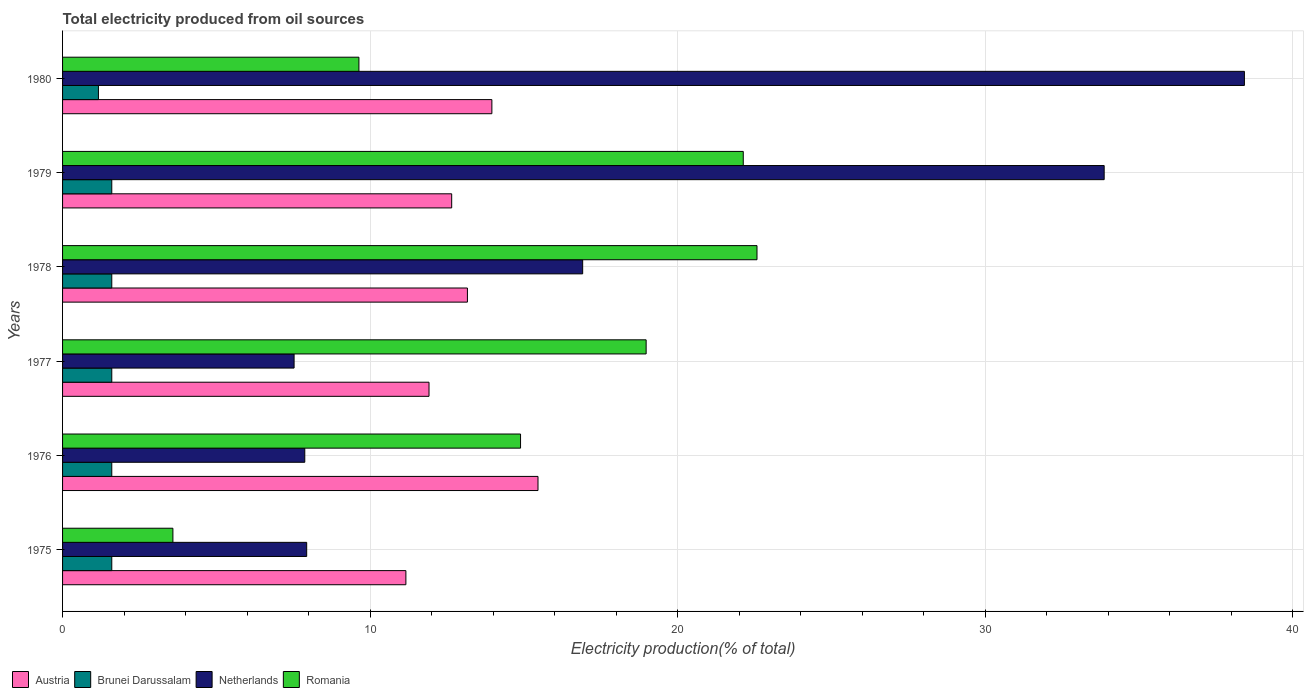How many bars are there on the 1st tick from the bottom?
Provide a short and direct response. 4. What is the label of the 5th group of bars from the top?
Give a very brief answer. 1976. In how many cases, is the number of bars for a given year not equal to the number of legend labels?
Offer a terse response. 0. What is the total electricity produced in Brunei Darussalam in 1977?
Your response must be concise. 1.6. Across all years, what is the minimum total electricity produced in Austria?
Your answer should be very brief. 11.16. In which year was the total electricity produced in Romania maximum?
Your answer should be compact. 1978. In which year was the total electricity produced in Romania minimum?
Your answer should be very brief. 1975. What is the total total electricity produced in Romania in the graph?
Ensure brevity in your answer.  91.79. What is the difference between the total electricity produced in Romania in 1975 and that in 1978?
Your answer should be compact. -18.99. What is the difference between the total electricity produced in Netherlands in 1980 and the total electricity produced in Romania in 1976?
Provide a succinct answer. 23.53. What is the average total electricity produced in Brunei Darussalam per year?
Provide a succinct answer. 1.53. In the year 1976, what is the difference between the total electricity produced in Netherlands and total electricity produced in Romania?
Provide a succinct answer. -7.01. What is the ratio of the total electricity produced in Romania in 1976 to that in 1978?
Keep it short and to the point. 0.66. Is the difference between the total electricity produced in Netherlands in 1978 and 1980 greater than the difference between the total electricity produced in Romania in 1978 and 1980?
Give a very brief answer. No. What is the difference between the highest and the second highest total electricity produced in Netherlands?
Keep it short and to the point. 4.56. What is the difference between the highest and the lowest total electricity produced in Romania?
Provide a succinct answer. 18.99. What does the 3rd bar from the top in 1975 represents?
Your answer should be very brief. Brunei Darussalam. What does the 4th bar from the bottom in 1978 represents?
Offer a terse response. Romania. Are all the bars in the graph horizontal?
Offer a very short reply. Yes. What is the difference between two consecutive major ticks on the X-axis?
Offer a terse response. 10. Are the values on the major ticks of X-axis written in scientific E-notation?
Ensure brevity in your answer.  No. Does the graph contain any zero values?
Give a very brief answer. No. Does the graph contain grids?
Your answer should be compact. Yes. Where does the legend appear in the graph?
Offer a terse response. Bottom left. How many legend labels are there?
Give a very brief answer. 4. How are the legend labels stacked?
Give a very brief answer. Horizontal. What is the title of the graph?
Offer a terse response. Total electricity produced from oil sources. What is the label or title of the X-axis?
Provide a short and direct response. Electricity production(% of total). What is the Electricity production(% of total) in Austria in 1975?
Keep it short and to the point. 11.16. What is the Electricity production(% of total) of Brunei Darussalam in 1975?
Offer a terse response. 1.6. What is the Electricity production(% of total) in Netherlands in 1975?
Keep it short and to the point. 7.94. What is the Electricity production(% of total) of Romania in 1975?
Offer a terse response. 3.59. What is the Electricity production(% of total) of Austria in 1976?
Your response must be concise. 15.46. What is the Electricity production(% of total) of Netherlands in 1976?
Your response must be concise. 7.87. What is the Electricity production(% of total) of Romania in 1976?
Your response must be concise. 14.89. What is the Electricity production(% of total) in Austria in 1977?
Provide a short and direct response. 11.91. What is the Electricity production(% of total) in Brunei Darussalam in 1977?
Offer a very short reply. 1.6. What is the Electricity production(% of total) of Netherlands in 1977?
Make the answer very short. 7.53. What is the Electricity production(% of total) of Romania in 1977?
Offer a terse response. 18.97. What is the Electricity production(% of total) of Austria in 1978?
Offer a terse response. 13.16. What is the Electricity production(% of total) in Brunei Darussalam in 1978?
Provide a short and direct response. 1.6. What is the Electricity production(% of total) of Netherlands in 1978?
Make the answer very short. 16.91. What is the Electricity production(% of total) of Romania in 1978?
Offer a terse response. 22.58. What is the Electricity production(% of total) in Austria in 1979?
Offer a very short reply. 12.65. What is the Electricity production(% of total) of Netherlands in 1979?
Provide a succinct answer. 33.86. What is the Electricity production(% of total) in Romania in 1979?
Make the answer very short. 22.13. What is the Electricity production(% of total) of Austria in 1980?
Offer a terse response. 13.96. What is the Electricity production(% of total) in Brunei Darussalam in 1980?
Provide a short and direct response. 1.17. What is the Electricity production(% of total) of Netherlands in 1980?
Provide a succinct answer. 38.42. What is the Electricity production(% of total) of Romania in 1980?
Your response must be concise. 9.63. Across all years, what is the maximum Electricity production(% of total) of Austria?
Your answer should be very brief. 15.46. Across all years, what is the maximum Electricity production(% of total) of Brunei Darussalam?
Your response must be concise. 1.6. Across all years, what is the maximum Electricity production(% of total) in Netherlands?
Your answer should be compact. 38.42. Across all years, what is the maximum Electricity production(% of total) in Romania?
Offer a very short reply. 22.58. Across all years, what is the minimum Electricity production(% of total) in Austria?
Provide a succinct answer. 11.16. Across all years, what is the minimum Electricity production(% of total) of Brunei Darussalam?
Provide a succinct answer. 1.17. Across all years, what is the minimum Electricity production(% of total) of Netherlands?
Your answer should be very brief. 7.53. Across all years, what is the minimum Electricity production(% of total) in Romania?
Offer a very short reply. 3.59. What is the total Electricity production(% of total) in Austria in the graph?
Your answer should be very brief. 78.3. What is the total Electricity production(% of total) of Brunei Darussalam in the graph?
Keep it short and to the point. 9.17. What is the total Electricity production(% of total) in Netherlands in the graph?
Provide a short and direct response. 112.53. What is the total Electricity production(% of total) of Romania in the graph?
Provide a succinct answer. 91.79. What is the difference between the Electricity production(% of total) of Austria in 1975 and that in 1976?
Keep it short and to the point. -4.29. What is the difference between the Electricity production(% of total) in Netherlands in 1975 and that in 1976?
Your answer should be compact. 0.06. What is the difference between the Electricity production(% of total) in Romania in 1975 and that in 1976?
Keep it short and to the point. -11.3. What is the difference between the Electricity production(% of total) in Austria in 1975 and that in 1977?
Keep it short and to the point. -0.75. What is the difference between the Electricity production(% of total) of Netherlands in 1975 and that in 1977?
Make the answer very short. 0.41. What is the difference between the Electricity production(% of total) of Romania in 1975 and that in 1977?
Make the answer very short. -15.38. What is the difference between the Electricity production(% of total) of Austria in 1975 and that in 1978?
Your answer should be compact. -2. What is the difference between the Electricity production(% of total) of Brunei Darussalam in 1975 and that in 1978?
Provide a short and direct response. 0. What is the difference between the Electricity production(% of total) of Netherlands in 1975 and that in 1978?
Offer a very short reply. -8.97. What is the difference between the Electricity production(% of total) of Romania in 1975 and that in 1978?
Your answer should be very brief. -18.99. What is the difference between the Electricity production(% of total) in Austria in 1975 and that in 1979?
Keep it short and to the point. -1.49. What is the difference between the Electricity production(% of total) in Brunei Darussalam in 1975 and that in 1979?
Ensure brevity in your answer.  0. What is the difference between the Electricity production(% of total) of Netherlands in 1975 and that in 1979?
Provide a short and direct response. -25.93. What is the difference between the Electricity production(% of total) in Romania in 1975 and that in 1979?
Offer a terse response. -18.54. What is the difference between the Electricity production(% of total) in Austria in 1975 and that in 1980?
Keep it short and to the point. -2.8. What is the difference between the Electricity production(% of total) in Brunei Darussalam in 1975 and that in 1980?
Your response must be concise. 0.43. What is the difference between the Electricity production(% of total) of Netherlands in 1975 and that in 1980?
Ensure brevity in your answer.  -30.48. What is the difference between the Electricity production(% of total) of Romania in 1975 and that in 1980?
Your answer should be compact. -6.05. What is the difference between the Electricity production(% of total) in Austria in 1976 and that in 1977?
Ensure brevity in your answer.  3.54. What is the difference between the Electricity production(% of total) in Netherlands in 1976 and that in 1977?
Provide a succinct answer. 0.35. What is the difference between the Electricity production(% of total) of Romania in 1976 and that in 1977?
Ensure brevity in your answer.  -4.08. What is the difference between the Electricity production(% of total) of Austria in 1976 and that in 1978?
Ensure brevity in your answer.  2.29. What is the difference between the Electricity production(% of total) in Netherlands in 1976 and that in 1978?
Offer a terse response. -9.03. What is the difference between the Electricity production(% of total) of Romania in 1976 and that in 1978?
Keep it short and to the point. -7.69. What is the difference between the Electricity production(% of total) of Austria in 1976 and that in 1979?
Ensure brevity in your answer.  2.81. What is the difference between the Electricity production(% of total) in Netherlands in 1976 and that in 1979?
Offer a very short reply. -25.99. What is the difference between the Electricity production(% of total) of Romania in 1976 and that in 1979?
Your response must be concise. -7.24. What is the difference between the Electricity production(% of total) in Austria in 1976 and that in 1980?
Keep it short and to the point. 1.5. What is the difference between the Electricity production(% of total) of Brunei Darussalam in 1976 and that in 1980?
Make the answer very short. 0.43. What is the difference between the Electricity production(% of total) of Netherlands in 1976 and that in 1980?
Your response must be concise. -30.55. What is the difference between the Electricity production(% of total) of Romania in 1976 and that in 1980?
Offer a terse response. 5.25. What is the difference between the Electricity production(% of total) in Austria in 1977 and that in 1978?
Give a very brief answer. -1.25. What is the difference between the Electricity production(% of total) in Netherlands in 1977 and that in 1978?
Make the answer very short. -9.38. What is the difference between the Electricity production(% of total) of Romania in 1977 and that in 1978?
Give a very brief answer. -3.6. What is the difference between the Electricity production(% of total) in Austria in 1977 and that in 1979?
Make the answer very short. -0.74. What is the difference between the Electricity production(% of total) of Netherlands in 1977 and that in 1979?
Provide a succinct answer. -26.34. What is the difference between the Electricity production(% of total) of Romania in 1977 and that in 1979?
Ensure brevity in your answer.  -3.16. What is the difference between the Electricity production(% of total) in Austria in 1977 and that in 1980?
Provide a short and direct response. -2.04. What is the difference between the Electricity production(% of total) in Brunei Darussalam in 1977 and that in 1980?
Your answer should be compact. 0.43. What is the difference between the Electricity production(% of total) in Netherlands in 1977 and that in 1980?
Your answer should be compact. -30.89. What is the difference between the Electricity production(% of total) of Romania in 1977 and that in 1980?
Your response must be concise. 9.34. What is the difference between the Electricity production(% of total) of Austria in 1978 and that in 1979?
Provide a short and direct response. 0.51. What is the difference between the Electricity production(% of total) in Brunei Darussalam in 1978 and that in 1979?
Offer a very short reply. 0. What is the difference between the Electricity production(% of total) of Netherlands in 1978 and that in 1979?
Make the answer very short. -16.95. What is the difference between the Electricity production(% of total) in Romania in 1978 and that in 1979?
Keep it short and to the point. 0.45. What is the difference between the Electricity production(% of total) in Austria in 1978 and that in 1980?
Your response must be concise. -0.79. What is the difference between the Electricity production(% of total) of Brunei Darussalam in 1978 and that in 1980?
Your answer should be compact. 0.43. What is the difference between the Electricity production(% of total) in Netherlands in 1978 and that in 1980?
Provide a short and direct response. -21.51. What is the difference between the Electricity production(% of total) in Romania in 1978 and that in 1980?
Your response must be concise. 12.94. What is the difference between the Electricity production(% of total) in Austria in 1979 and that in 1980?
Make the answer very short. -1.31. What is the difference between the Electricity production(% of total) of Brunei Darussalam in 1979 and that in 1980?
Give a very brief answer. 0.43. What is the difference between the Electricity production(% of total) of Netherlands in 1979 and that in 1980?
Ensure brevity in your answer.  -4.56. What is the difference between the Electricity production(% of total) in Romania in 1979 and that in 1980?
Your answer should be very brief. 12.49. What is the difference between the Electricity production(% of total) in Austria in 1975 and the Electricity production(% of total) in Brunei Darussalam in 1976?
Your answer should be compact. 9.56. What is the difference between the Electricity production(% of total) in Austria in 1975 and the Electricity production(% of total) in Netherlands in 1976?
Your answer should be very brief. 3.29. What is the difference between the Electricity production(% of total) in Austria in 1975 and the Electricity production(% of total) in Romania in 1976?
Your response must be concise. -3.73. What is the difference between the Electricity production(% of total) in Brunei Darussalam in 1975 and the Electricity production(% of total) in Netherlands in 1976?
Provide a short and direct response. -6.27. What is the difference between the Electricity production(% of total) in Brunei Darussalam in 1975 and the Electricity production(% of total) in Romania in 1976?
Offer a terse response. -13.29. What is the difference between the Electricity production(% of total) in Netherlands in 1975 and the Electricity production(% of total) in Romania in 1976?
Offer a terse response. -6.95. What is the difference between the Electricity production(% of total) in Austria in 1975 and the Electricity production(% of total) in Brunei Darussalam in 1977?
Offer a very short reply. 9.56. What is the difference between the Electricity production(% of total) in Austria in 1975 and the Electricity production(% of total) in Netherlands in 1977?
Keep it short and to the point. 3.63. What is the difference between the Electricity production(% of total) of Austria in 1975 and the Electricity production(% of total) of Romania in 1977?
Provide a short and direct response. -7.81. What is the difference between the Electricity production(% of total) in Brunei Darussalam in 1975 and the Electricity production(% of total) in Netherlands in 1977?
Keep it short and to the point. -5.93. What is the difference between the Electricity production(% of total) of Brunei Darussalam in 1975 and the Electricity production(% of total) of Romania in 1977?
Your answer should be compact. -17.37. What is the difference between the Electricity production(% of total) in Netherlands in 1975 and the Electricity production(% of total) in Romania in 1977?
Make the answer very short. -11.04. What is the difference between the Electricity production(% of total) in Austria in 1975 and the Electricity production(% of total) in Brunei Darussalam in 1978?
Provide a succinct answer. 9.56. What is the difference between the Electricity production(% of total) in Austria in 1975 and the Electricity production(% of total) in Netherlands in 1978?
Provide a short and direct response. -5.75. What is the difference between the Electricity production(% of total) in Austria in 1975 and the Electricity production(% of total) in Romania in 1978?
Ensure brevity in your answer.  -11.41. What is the difference between the Electricity production(% of total) in Brunei Darussalam in 1975 and the Electricity production(% of total) in Netherlands in 1978?
Provide a succinct answer. -15.31. What is the difference between the Electricity production(% of total) in Brunei Darussalam in 1975 and the Electricity production(% of total) in Romania in 1978?
Your answer should be very brief. -20.98. What is the difference between the Electricity production(% of total) in Netherlands in 1975 and the Electricity production(% of total) in Romania in 1978?
Keep it short and to the point. -14.64. What is the difference between the Electricity production(% of total) of Austria in 1975 and the Electricity production(% of total) of Brunei Darussalam in 1979?
Offer a very short reply. 9.56. What is the difference between the Electricity production(% of total) in Austria in 1975 and the Electricity production(% of total) in Netherlands in 1979?
Offer a very short reply. -22.7. What is the difference between the Electricity production(% of total) of Austria in 1975 and the Electricity production(% of total) of Romania in 1979?
Provide a succinct answer. -10.97. What is the difference between the Electricity production(% of total) in Brunei Darussalam in 1975 and the Electricity production(% of total) in Netherlands in 1979?
Provide a short and direct response. -32.26. What is the difference between the Electricity production(% of total) of Brunei Darussalam in 1975 and the Electricity production(% of total) of Romania in 1979?
Offer a terse response. -20.53. What is the difference between the Electricity production(% of total) of Netherlands in 1975 and the Electricity production(% of total) of Romania in 1979?
Keep it short and to the point. -14.19. What is the difference between the Electricity production(% of total) of Austria in 1975 and the Electricity production(% of total) of Brunei Darussalam in 1980?
Provide a short and direct response. 10. What is the difference between the Electricity production(% of total) of Austria in 1975 and the Electricity production(% of total) of Netherlands in 1980?
Your response must be concise. -27.26. What is the difference between the Electricity production(% of total) of Austria in 1975 and the Electricity production(% of total) of Romania in 1980?
Your answer should be compact. 1.53. What is the difference between the Electricity production(% of total) in Brunei Darussalam in 1975 and the Electricity production(% of total) in Netherlands in 1980?
Make the answer very short. -36.82. What is the difference between the Electricity production(% of total) in Brunei Darussalam in 1975 and the Electricity production(% of total) in Romania in 1980?
Your answer should be compact. -8.03. What is the difference between the Electricity production(% of total) of Netherlands in 1975 and the Electricity production(% of total) of Romania in 1980?
Give a very brief answer. -1.7. What is the difference between the Electricity production(% of total) of Austria in 1976 and the Electricity production(% of total) of Brunei Darussalam in 1977?
Provide a succinct answer. 13.86. What is the difference between the Electricity production(% of total) of Austria in 1976 and the Electricity production(% of total) of Netherlands in 1977?
Your response must be concise. 7.93. What is the difference between the Electricity production(% of total) of Austria in 1976 and the Electricity production(% of total) of Romania in 1977?
Ensure brevity in your answer.  -3.52. What is the difference between the Electricity production(% of total) of Brunei Darussalam in 1976 and the Electricity production(% of total) of Netherlands in 1977?
Offer a terse response. -5.93. What is the difference between the Electricity production(% of total) in Brunei Darussalam in 1976 and the Electricity production(% of total) in Romania in 1977?
Your response must be concise. -17.37. What is the difference between the Electricity production(% of total) in Netherlands in 1976 and the Electricity production(% of total) in Romania in 1977?
Ensure brevity in your answer.  -11.1. What is the difference between the Electricity production(% of total) in Austria in 1976 and the Electricity production(% of total) in Brunei Darussalam in 1978?
Ensure brevity in your answer.  13.86. What is the difference between the Electricity production(% of total) in Austria in 1976 and the Electricity production(% of total) in Netherlands in 1978?
Offer a very short reply. -1.45. What is the difference between the Electricity production(% of total) of Austria in 1976 and the Electricity production(% of total) of Romania in 1978?
Offer a very short reply. -7.12. What is the difference between the Electricity production(% of total) in Brunei Darussalam in 1976 and the Electricity production(% of total) in Netherlands in 1978?
Keep it short and to the point. -15.31. What is the difference between the Electricity production(% of total) of Brunei Darussalam in 1976 and the Electricity production(% of total) of Romania in 1978?
Provide a short and direct response. -20.98. What is the difference between the Electricity production(% of total) in Netherlands in 1976 and the Electricity production(% of total) in Romania in 1978?
Your answer should be very brief. -14.7. What is the difference between the Electricity production(% of total) in Austria in 1976 and the Electricity production(% of total) in Brunei Darussalam in 1979?
Provide a short and direct response. 13.86. What is the difference between the Electricity production(% of total) in Austria in 1976 and the Electricity production(% of total) in Netherlands in 1979?
Keep it short and to the point. -18.41. What is the difference between the Electricity production(% of total) of Austria in 1976 and the Electricity production(% of total) of Romania in 1979?
Your response must be concise. -6.67. What is the difference between the Electricity production(% of total) of Brunei Darussalam in 1976 and the Electricity production(% of total) of Netherlands in 1979?
Your answer should be compact. -32.26. What is the difference between the Electricity production(% of total) in Brunei Darussalam in 1976 and the Electricity production(% of total) in Romania in 1979?
Keep it short and to the point. -20.53. What is the difference between the Electricity production(% of total) of Netherlands in 1976 and the Electricity production(% of total) of Romania in 1979?
Your response must be concise. -14.25. What is the difference between the Electricity production(% of total) of Austria in 1976 and the Electricity production(% of total) of Brunei Darussalam in 1980?
Keep it short and to the point. 14.29. What is the difference between the Electricity production(% of total) of Austria in 1976 and the Electricity production(% of total) of Netherlands in 1980?
Provide a succinct answer. -22.96. What is the difference between the Electricity production(% of total) of Austria in 1976 and the Electricity production(% of total) of Romania in 1980?
Offer a terse response. 5.82. What is the difference between the Electricity production(% of total) in Brunei Darussalam in 1976 and the Electricity production(% of total) in Netherlands in 1980?
Your answer should be very brief. -36.82. What is the difference between the Electricity production(% of total) of Brunei Darussalam in 1976 and the Electricity production(% of total) of Romania in 1980?
Your response must be concise. -8.03. What is the difference between the Electricity production(% of total) in Netherlands in 1976 and the Electricity production(% of total) in Romania in 1980?
Keep it short and to the point. -1.76. What is the difference between the Electricity production(% of total) in Austria in 1977 and the Electricity production(% of total) in Brunei Darussalam in 1978?
Make the answer very short. 10.31. What is the difference between the Electricity production(% of total) in Austria in 1977 and the Electricity production(% of total) in Netherlands in 1978?
Your answer should be compact. -5. What is the difference between the Electricity production(% of total) of Austria in 1977 and the Electricity production(% of total) of Romania in 1978?
Give a very brief answer. -10.66. What is the difference between the Electricity production(% of total) in Brunei Darussalam in 1977 and the Electricity production(% of total) in Netherlands in 1978?
Provide a short and direct response. -15.31. What is the difference between the Electricity production(% of total) of Brunei Darussalam in 1977 and the Electricity production(% of total) of Romania in 1978?
Your answer should be compact. -20.98. What is the difference between the Electricity production(% of total) in Netherlands in 1977 and the Electricity production(% of total) in Romania in 1978?
Your answer should be very brief. -15.05. What is the difference between the Electricity production(% of total) in Austria in 1977 and the Electricity production(% of total) in Brunei Darussalam in 1979?
Your answer should be very brief. 10.31. What is the difference between the Electricity production(% of total) of Austria in 1977 and the Electricity production(% of total) of Netherlands in 1979?
Keep it short and to the point. -21.95. What is the difference between the Electricity production(% of total) of Austria in 1977 and the Electricity production(% of total) of Romania in 1979?
Your response must be concise. -10.22. What is the difference between the Electricity production(% of total) of Brunei Darussalam in 1977 and the Electricity production(% of total) of Netherlands in 1979?
Give a very brief answer. -32.26. What is the difference between the Electricity production(% of total) in Brunei Darussalam in 1977 and the Electricity production(% of total) in Romania in 1979?
Offer a very short reply. -20.53. What is the difference between the Electricity production(% of total) of Netherlands in 1977 and the Electricity production(% of total) of Romania in 1979?
Keep it short and to the point. -14.6. What is the difference between the Electricity production(% of total) in Austria in 1977 and the Electricity production(% of total) in Brunei Darussalam in 1980?
Ensure brevity in your answer.  10.75. What is the difference between the Electricity production(% of total) of Austria in 1977 and the Electricity production(% of total) of Netherlands in 1980?
Give a very brief answer. -26.51. What is the difference between the Electricity production(% of total) of Austria in 1977 and the Electricity production(% of total) of Romania in 1980?
Make the answer very short. 2.28. What is the difference between the Electricity production(% of total) of Brunei Darussalam in 1977 and the Electricity production(% of total) of Netherlands in 1980?
Offer a very short reply. -36.82. What is the difference between the Electricity production(% of total) of Brunei Darussalam in 1977 and the Electricity production(% of total) of Romania in 1980?
Offer a very short reply. -8.03. What is the difference between the Electricity production(% of total) in Netherlands in 1977 and the Electricity production(% of total) in Romania in 1980?
Keep it short and to the point. -2.11. What is the difference between the Electricity production(% of total) in Austria in 1978 and the Electricity production(% of total) in Brunei Darussalam in 1979?
Give a very brief answer. 11.56. What is the difference between the Electricity production(% of total) of Austria in 1978 and the Electricity production(% of total) of Netherlands in 1979?
Provide a succinct answer. -20.7. What is the difference between the Electricity production(% of total) in Austria in 1978 and the Electricity production(% of total) in Romania in 1979?
Provide a succinct answer. -8.97. What is the difference between the Electricity production(% of total) in Brunei Darussalam in 1978 and the Electricity production(% of total) in Netherlands in 1979?
Your answer should be compact. -32.26. What is the difference between the Electricity production(% of total) of Brunei Darussalam in 1978 and the Electricity production(% of total) of Romania in 1979?
Offer a terse response. -20.53. What is the difference between the Electricity production(% of total) of Netherlands in 1978 and the Electricity production(% of total) of Romania in 1979?
Ensure brevity in your answer.  -5.22. What is the difference between the Electricity production(% of total) of Austria in 1978 and the Electricity production(% of total) of Brunei Darussalam in 1980?
Your answer should be very brief. 12. What is the difference between the Electricity production(% of total) in Austria in 1978 and the Electricity production(% of total) in Netherlands in 1980?
Provide a succinct answer. -25.26. What is the difference between the Electricity production(% of total) in Austria in 1978 and the Electricity production(% of total) in Romania in 1980?
Provide a short and direct response. 3.53. What is the difference between the Electricity production(% of total) in Brunei Darussalam in 1978 and the Electricity production(% of total) in Netherlands in 1980?
Provide a short and direct response. -36.82. What is the difference between the Electricity production(% of total) in Brunei Darussalam in 1978 and the Electricity production(% of total) in Romania in 1980?
Offer a terse response. -8.03. What is the difference between the Electricity production(% of total) of Netherlands in 1978 and the Electricity production(% of total) of Romania in 1980?
Your answer should be very brief. 7.27. What is the difference between the Electricity production(% of total) of Austria in 1979 and the Electricity production(% of total) of Brunei Darussalam in 1980?
Ensure brevity in your answer.  11.48. What is the difference between the Electricity production(% of total) of Austria in 1979 and the Electricity production(% of total) of Netherlands in 1980?
Ensure brevity in your answer.  -25.77. What is the difference between the Electricity production(% of total) in Austria in 1979 and the Electricity production(% of total) in Romania in 1980?
Ensure brevity in your answer.  3.02. What is the difference between the Electricity production(% of total) in Brunei Darussalam in 1979 and the Electricity production(% of total) in Netherlands in 1980?
Your answer should be very brief. -36.82. What is the difference between the Electricity production(% of total) in Brunei Darussalam in 1979 and the Electricity production(% of total) in Romania in 1980?
Ensure brevity in your answer.  -8.03. What is the difference between the Electricity production(% of total) of Netherlands in 1979 and the Electricity production(% of total) of Romania in 1980?
Provide a short and direct response. 24.23. What is the average Electricity production(% of total) in Austria per year?
Provide a succinct answer. 13.05. What is the average Electricity production(% of total) in Brunei Darussalam per year?
Make the answer very short. 1.53. What is the average Electricity production(% of total) in Netherlands per year?
Provide a succinct answer. 18.75. What is the average Electricity production(% of total) of Romania per year?
Provide a succinct answer. 15.3. In the year 1975, what is the difference between the Electricity production(% of total) of Austria and Electricity production(% of total) of Brunei Darussalam?
Provide a succinct answer. 9.56. In the year 1975, what is the difference between the Electricity production(% of total) in Austria and Electricity production(% of total) in Netherlands?
Offer a very short reply. 3.23. In the year 1975, what is the difference between the Electricity production(% of total) in Austria and Electricity production(% of total) in Romania?
Offer a very short reply. 7.57. In the year 1975, what is the difference between the Electricity production(% of total) in Brunei Darussalam and Electricity production(% of total) in Netherlands?
Provide a succinct answer. -6.34. In the year 1975, what is the difference between the Electricity production(% of total) of Brunei Darussalam and Electricity production(% of total) of Romania?
Make the answer very short. -1.99. In the year 1975, what is the difference between the Electricity production(% of total) in Netherlands and Electricity production(% of total) in Romania?
Provide a succinct answer. 4.35. In the year 1976, what is the difference between the Electricity production(% of total) in Austria and Electricity production(% of total) in Brunei Darussalam?
Provide a short and direct response. 13.86. In the year 1976, what is the difference between the Electricity production(% of total) in Austria and Electricity production(% of total) in Netherlands?
Keep it short and to the point. 7.58. In the year 1976, what is the difference between the Electricity production(% of total) in Austria and Electricity production(% of total) in Romania?
Offer a very short reply. 0.57. In the year 1976, what is the difference between the Electricity production(% of total) in Brunei Darussalam and Electricity production(% of total) in Netherlands?
Provide a succinct answer. -6.27. In the year 1976, what is the difference between the Electricity production(% of total) in Brunei Darussalam and Electricity production(% of total) in Romania?
Offer a very short reply. -13.29. In the year 1976, what is the difference between the Electricity production(% of total) of Netherlands and Electricity production(% of total) of Romania?
Keep it short and to the point. -7.01. In the year 1977, what is the difference between the Electricity production(% of total) of Austria and Electricity production(% of total) of Brunei Darussalam?
Your answer should be very brief. 10.31. In the year 1977, what is the difference between the Electricity production(% of total) of Austria and Electricity production(% of total) of Netherlands?
Keep it short and to the point. 4.39. In the year 1977, what is the difference between the Electricity production(% of total) in Austria and Electricity production(% of total) in Romania?
Make the answer very short. -7.06. In the year 1977, what is the difference between the Electricity production(% of total) of Brunei Darussalam and Electricity production(% of total) of Netherlands?
Offer a terse response. -5.93. In the year 1977, what is the difference between the Electricity production(% of total) of Brunei Darussalam and Electricity production(% of total) of Romania?
Offer a very short reply. -17.37. In the year 1977, what is the difference between the Electricity production(% of total) of Netherlands and Electricity production(% of total) of Romania?
Make the answer very short. -11.44. In the year 1978, what is the difference between the Electricity production(% of total) in Austria and Electricity production(% of total) in Brunei Darussalam?
Your answer should be very brief. 11.56. In the year 1978, what is the difference between the Electricity production(% of total) in Austria and Electricity production(% of total) in Netherlands?
Your answer should be compact. -3.75. In the year 1978, what is the difference between the Electricity production(% of total) in Austria and Electricity production(% of total) in Romania?
Give a very brief answer. -9.41. In the year 1978, what is the difference between the Electricity production(% of total) of Brunei Darussalam and Electricity production(% of total) of Netherlands?
Provide a succinct answer. -15.31. In the year 1978, what is the difference between the Electricity production(% of total) of Brunei Darussalam and Electricity production(% of total) of Romania?
Ensure brevity in your answer.  -20.98. In the year 1978, what is the difference between the Electricity production(% of total) in Netherlands and Electricity production(% of total) in Romania?
Keep it short and to the point. -5.67. In the year 1979, what is the difference between the Electricity production(% of total) of Austria and Electricity production(% of total) of Brunei Darussalam?
Your answer should be very brief. 11.05. In the year 1979, what is the difference between the Electricity production(% of total) in Austria and Electricity production(% of total) in Netherlands?
Ensure brevity in your answer.  -21.21. In the year 1979, what is the difference between the Electricity production(% of total) in Austria and Electricity production(% of total) in Romania?
Provide a succinct answer. -9.48. In the year 1979, what is the difference between the Electricity production(% of total) of Brunei Darussalam and Electricity production(% of total) of Netherlands?
Ensure brevity in your answer.  -32.26. In the year 1979, what is the difference between the Electricity production(% of total) of Brunei Darussalam and Electricity production(% of total) of Romania?
Provide a succinct answer. -20.53. In the year 1979, what is the difference between the Electricity production(% of total) in Netherlands and Electricity production(% of total) in Romania?
Your answer should be very brief. 11.73. In the year 1980, what is the difference between the Electricity production(% of total) of Austria and Electricity production(% of total) of Brunei Darussalam?
Provide a succinct answer. 12.79. In the year 1980, what is the difference between the Electricity production(% of total) of Austria and Electricity production(% of total) of Netherlands?
Provide a short and direct response. -24.46. In the year 1980, what is the difference between the Electricity production(% of total) in Austria and Electricity production(% of total) in Romania?
Give a very brief answer. 4.32. In the year 1980, what is the difference between the Electricity production(% of total) of Brunei Darussalam and Electricity production(% of total) of Netherlands?
Provide a succinct answer. -37.25. In the year 1980, what is the difference between the Electricity production(% of total) of Brunei Darussalam and Electricity production(% of total) of Romania?
Make the answer very short. -8.47. In the year 1980, what is the difference between the Electricity production(% of total) of Netherlands and Electricity production(% of total) of Romania?
Make the answer very short. 28.79. What is the ratio of the Electricity production(% of total) in Austria in 1975 to that in 1976?
Provide a succinct answer. 0.72. What is the ratio of the Electricity production(% of total) of Brunei Darussalam in 1975 to that in 1976?
Offer a very short reply. 1. What is the ratio of the Electricity production(% of total) in Romania in 1975 to that in 1976?
Your response must be concise. 0.24. What is the ratio of the Electricity production(% of total) in Austria in 1975 to that in 1977?
Your response must be concise. 0.94. What is the ratio of the Electricity production(% of total) in Brunei Darussalam in 1975 to that in 1977?
Offer a very short reply. 1. What is the ratio of the Electricity production(% of total) of Netherlands in 1975 to that in 1977?
Your response must be concise. 1.05. What is the ratio of the Electricity production(% of total) of Romania in 1975 to that in 1977?
Give a very brief answer. 0.19. What is the ratio of the Electricity production(% of total) of Austria in 1975 to that in 1978?
Give a very brief answer. 0.85. What is the ratio of the Electricity production(% of total) of Brunei Darussalam in 1975 to that in 1978?
Keep it short and to the point. 1. What is the ratio of the Electricity production(% of total) of Netherlands in 1975 to that in 1978?
Provide a succinct answer. 0.47. What is the ratio of the Electricity production(% of total) of Romania in 1975 to that in 1978?
Offer a very short reply. 0.16. What is the ratio of the Electricity production(% of total) in Austria in 1975 to that in 1979?
Make the answer very short. 0.88. What is the ratio of the Electricity production(% of total) in Brunei Darussalam in 1975 to that in 1979?
Your response must be concise. 1. What is the ratio of the Electricity production(% of total) of Netherlands in 1975 to that in 1979?
Your answer should be compact. 0.23. What is the ratio of the Electricity production(% of total) in Romania in 1975 to that in 1979?
Make the answer very short. 0.16. What is the ratio of the Electricity production(% of total) of Austria in 1975 to that in 1980?
Offer a terse response. 0.8. What is the ratio of the Electricity production(% of total) in Brunei Darussalam in 1975 to that in 1980?
Provide a succinct answer. 1.37. What is the ratio of the Electricity production(% of total) in Netherlands in 1975 to that in 1980?
Ensure brevity in your answer.  0.21. What is the ratio of the Electricity production(% of total) in Romania in 1975 to that in 1980?
Provide a succinct answer. 0.37. What is the ratio of the Electricity production(% of total) of Austria in 1976 to that in 1977?
Make the answer very short. 1.3. What is the ratio of the Electricity production(% of total) in Netherlands in 1976 to that in 1977?
Your response must be concise. 1.05. What is the ratio of the Electricity production(% of total) of Romania in 1976 to that in 1977?
Offer a terse response. 0.78. What is the ratio of the Electricity production(% of total) of Austria in 1976 to that in 1978?
Offer a very short reply. 1.17. What is the ratio of the Electricity production(% of total) of Brunei Darussalam in 1976 to that in 1978?
Your response must be concise. 1. What is the ratio of the Electricity production(% of total) of Netherlands in 1976 to that in 1978?
Ensure brevity in your answer.  0.47. What is the ratio of the Electricity production(% of total) in Romania in 1976 to that in 1978?
Your answer should be compact. 0.66. What is the ratio of the Electricity production(% of total) in Austria in 1976 to that in 1979?
Keep it short and to the point. 1.22. What is the ratio of the Electricity production(% of total) in Brunei Darussalam in 1976 to that in 1979?
Offer a terse response. 1. What is the ratio of the Electricity production(% of total) in Netherlands in 1976 to that in 1979?
Provide a short and direct response. 0.23. What is the ratio of the Electricity production(% of total) in Romania in 1976 to that in 1979?
Give a very brief answer. 0.67. What is the ratio of the Electricity production(% of total) in Austria in 1976 to that in 1980?
Provide a short and direct response. 1.11. What is the ratio of the Electricity production(% of total) of Brunei Darussalam in 1976 to that in 1980?
Offer a very short reply. 1.37. What is the ratio of the Electricity production(% of total) in Netherlands in 1976 to that in 1980?
Make the answer very short. 0.2. What is the ratio of the Electricity production(% of total) in Romania in 1976 to that in 1980?
Offer a very short reply. 1.55. What is the ratio of the Electricity production(% of total) of Austria in 1977 to that in 1978?
Provide a succinct answer. 0.91. What is the ratio of the Electricity production(% of total) in Netherlands in 1977 to that in 1978?
Make the answer very short. 0.45. What is the ratio of the Electricity production(% of total) of Romania in 1977 to that in 1978?
Give a very brief answer. 0.84. What is the ratio of the Electricity production(% of total) of Austria in 1977 to that in 1979?
Your answer should be very brief. 0.94. What is the ratio of the Electricity production(% of total) of Brunei Darussalam in 1977 to that in 1979?
Your answer should be very brief. 1. What is the ratio of the Electricity production(% of total) in Netherlands in 1977 to that in 1979?
Provide a succinct answer. 0.22. What is the ratio of the Electricity production(% of total) of Romania in 1977 to that in 1979?
Offer a terse response. 0.86. What is the ratio of the Electricity production(% of total) of Austria in 1977 to that in 1980?
Your answer should be compact. 0.85. What is the ratio of the Electricity production(% of total) in Brunei Darussalam in 1977 to that in 1980?
Offer a terse response. 1.37. What is the ratio of the Electricity production(% of total) of Netherlands in 1977 to that in 1980?
Give a very brief answer. 0.2. What is the ratio of the Electricity production(% of total) of Romania in 1977 to that in 1980?
Your answer should be compact. 1.97. What is the ratio of the Electricity production(% of total) of Austria in 1978 to that in 1979?
Keep it short and to the point. 1.04. What is the ratio of the Electricity production(% of total) of Brunei Darussalam in 1978 to that in 1979?
Ensure brevity in your answer.  1. What is the ratio of the Electricity production(% of total) of Netherlands in 1978 to that in 1979?
Your answer should be very brief. 0.5. What is the ratio of the Electricity production(% of total) of Romania in 1978 to that in 1979?
Keep it short and to the point. 1.02. What is the ratio of the Electricity production(% of total) in Austria in 1978 to that in 1980?
Your response must be concise. 0.94. What is the ratio of the Electricity production(% of total) of Brunei Darussalam in 1978 to that in 1980?
Your answer should be very brief. 1.37. What is the ratio of the Electricity production(% of total) of Netherlands in 1978 to that in 1980?
Your answer should be very brief. 0.44. What is the ratio of the Electricity production(% of total) of Romania in 1978 to that in 1980?
Your answer should be very brief. 2.34. What is the ratio of the Electricity production(% of total) of Austria in 1979 to that in 1980?
Offer a terse response. 0.91. What is the ratio of the Electricity production(% of total) in Brunei Darussalam in 1979 to that in 1980?
Offer a terse response. 1.37. What is the ratio of the Electricity production(% of total) in Netherlands in 1979 to that in 1980?
Provide a short and direct response. 0.88. What is the ratio of the Electricity production(% of total) of Romania in 1979 to that in 1980?
Provide a short and direct response. 2.3. What is the difference between the highest and the second highest Electricity production(% of total) in Austria?
Your response must be concise. 1.5. What is the difference between the highest and the second highest Electricity production(% of total) in Brunei Darussalam?
Keep it short and to the point. 0. What is the difference between the highest and the second highest Electricity production(% of total) of Netherlands?
Your response must be concise. 4.56. What is the difference between the highest and the second highest Electricity production(% of total) of Romania?
Your answer should be very brief. 0.45. What is the difference between the highest and the lowest Electricity production(% of total) of Austria?
Your answer should be compact. 4.29. What is the difference between the highest and the lowest Electricity production(% of total) in Brunei Darussalam?
Ensure brevity in your answer.  0.43. What is the difference between the highest and the lowest Electricity production(% of total) in Netherlands?
Give a very brief answer. 30.89. What is the difference between the highest and the lowest Electricity production(% of total) in Romania?
Offer a terse response. 18.99. 